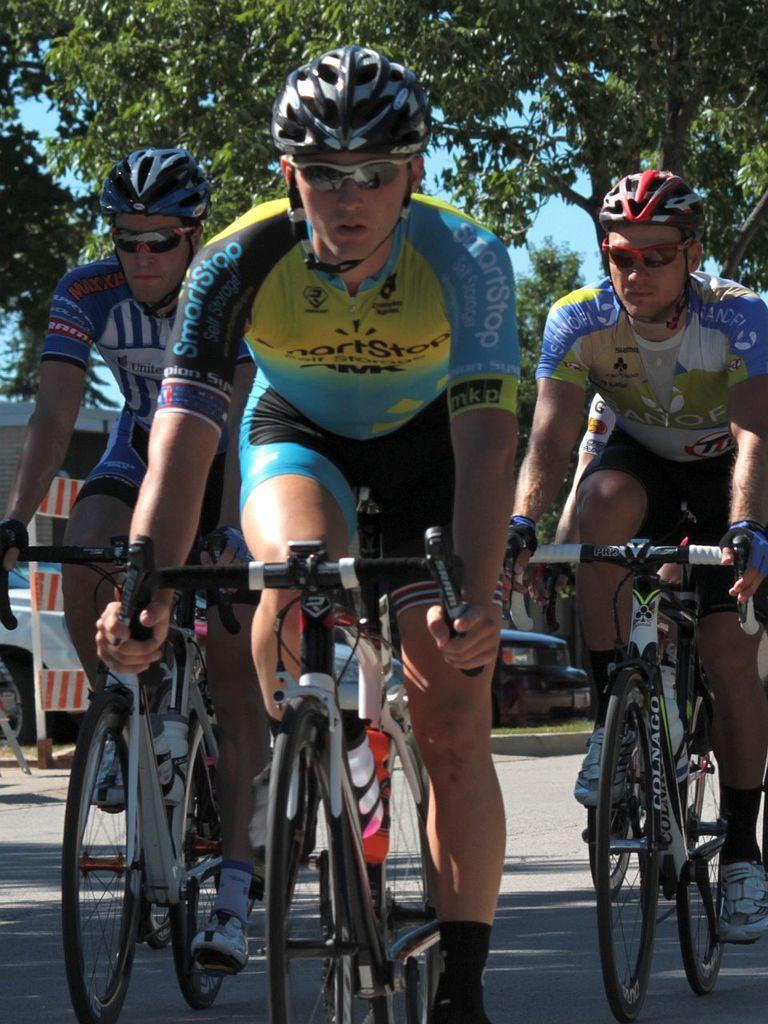What type of vegetation can be seen in the image? There are trees in the image. How many people are present in the image? There are three people in the image. What are the people doing in the image? The people are riding bicycles. What type of smoke can be seen coming from the trees in the image? There is no smoke present in the image; it features trees and people riding bicycles. Is there a party happening in the image? There is no indication of a party in the image; it only shows trees, people, and bicycles. 